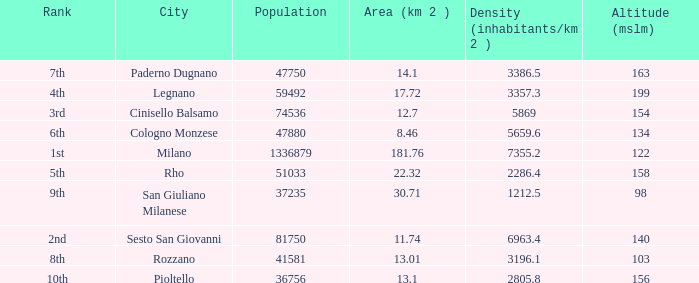Which Altitude (mslm) is the highest one that has a City of legnano, and a Population larger than 59492? None. 